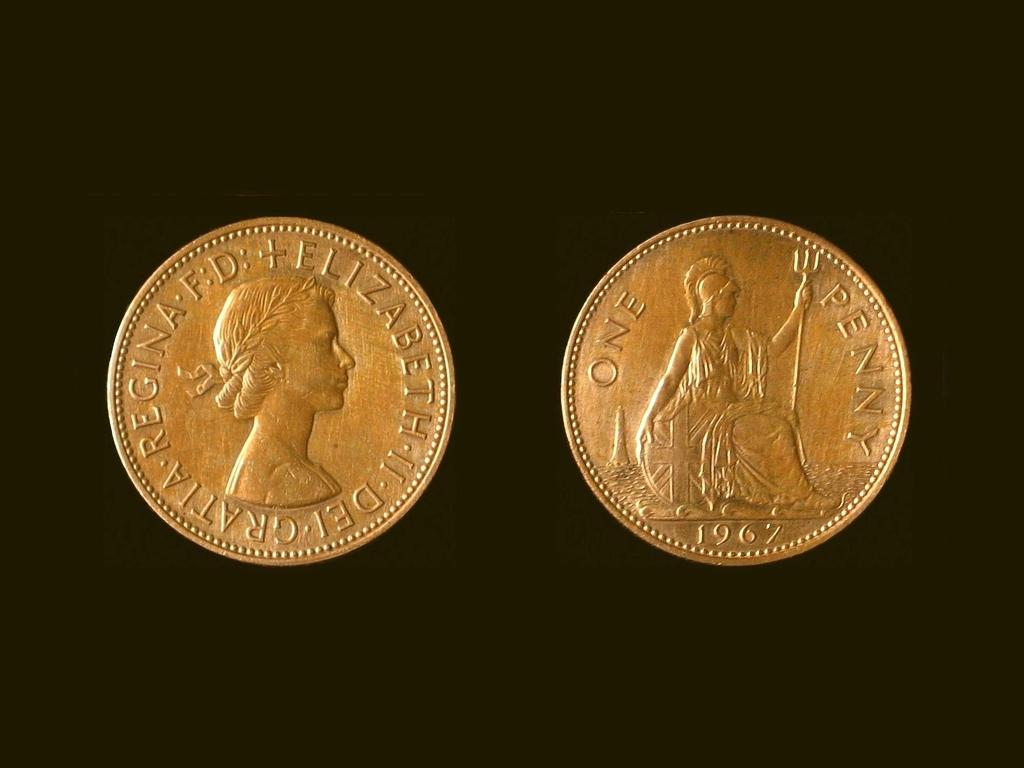Provide a one-sentence caption for the provided image. Two coins that say One Penny from 1967. 